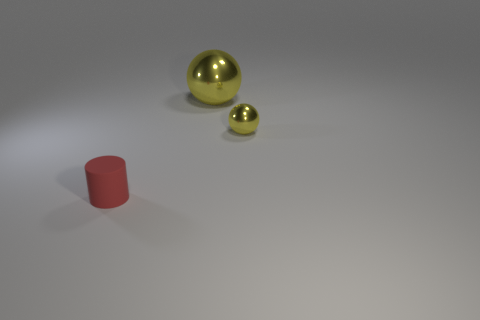There is a tiny metal object that is the same shape as the big yellow metal thing; what is its color?
Ensure brevity in your answer.  Yellow. Is the material of the small object right of the red matte cylinder the same as the ball behind the small shiny ball?
Keep it short and to the point. Yes. Do the big shiny sphere and the small thing behind the red matte thing have the same color?
Your answer should be very brief. Yes. The thing that is both in front of the large metallic ball and behind the rubber cylinder has what shape?
Offer a terse response. Sphere. How many large yellow shiny objects are there?
Your answer should be very brief. 1. There is a shiny object that is the same color as the small metal sphere; what shape is it?
Provide a succinct answer. Sphere. What is the size of the other object that is the same shape as the small yellow object?
Ensure brevity in your answer.  Large. Is the shape of the tiny thing behind the tiny cylinder the same as  the small red thing?
Ensure brevity in your answer.  No. What color is the ball that is in front of the large thing?
Make the answer very short. Yellow. What number of other objects are there of the same size as the cylinder?
Offer a very short reply. 1. 